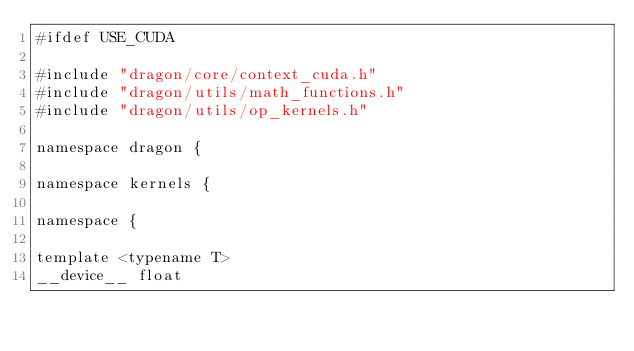Convert code to text. <code><loc_0><loc_0><loc_500><loc_500><_Cuda_>#ifdef USE_CUDA

#include "dragon/core/context_cuda.h"
#include "dragon/utils/math_functions.h"
#include "dragon/utils/op_kernels.h"

namespace dragon {

namespace kernels {

namespace {

template <typename T>
__device__ float</code> 